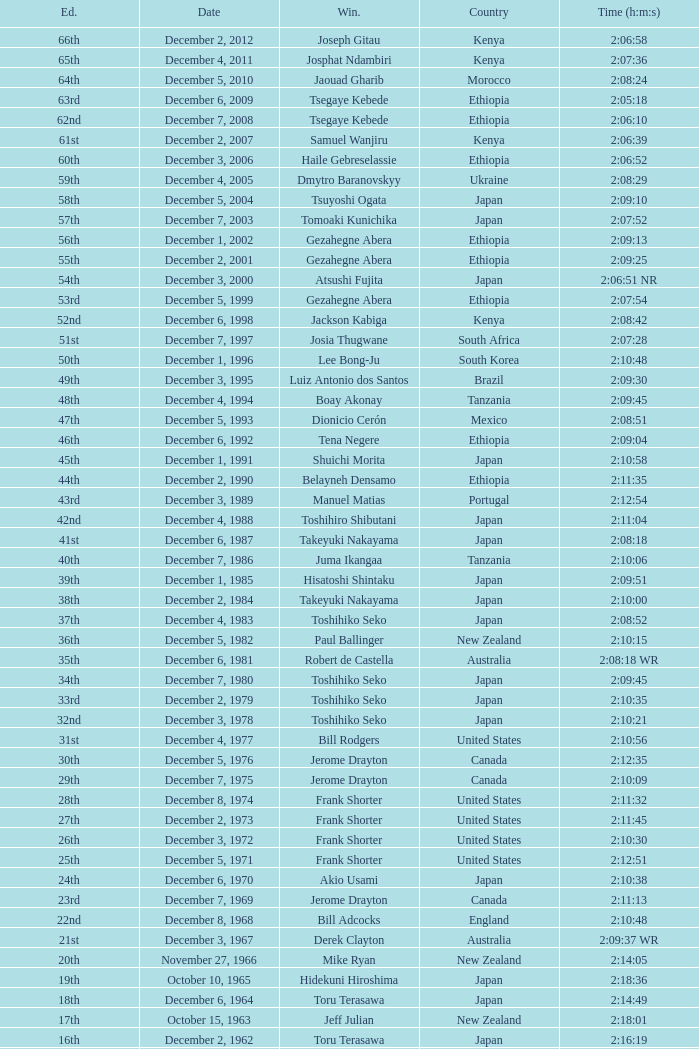Who was the winner of the 23rd Edition? Jerome Drayton. 